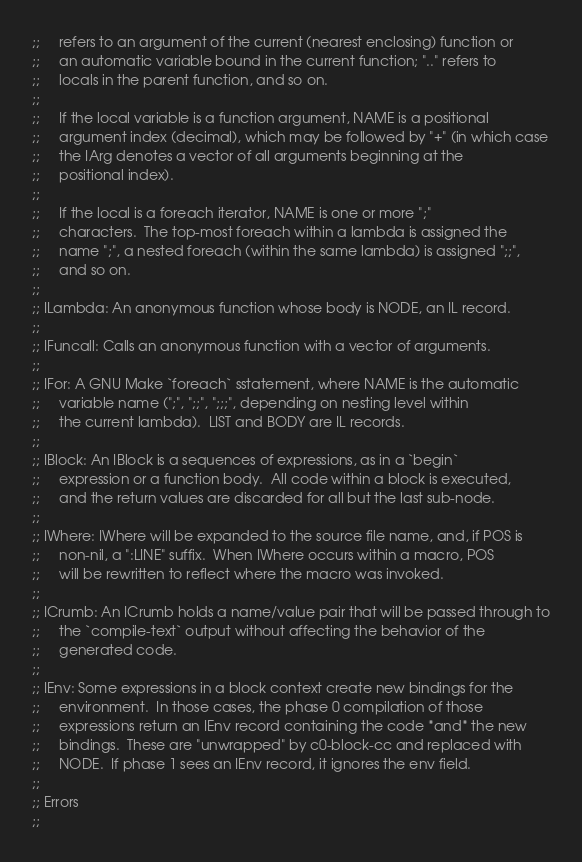<code> <loc_0><loc_0><loc_500><loc_500><_Scheme_>;;     refers to an argument of the current (nearest enclosing) function or
;;     an automatic variable bound in the current function; ".." refers to
;;     locals in the parent function, and so on.
;;
;;     If the local variable is a function argument, NAME is a positional
;;     argument index (decimal), which may be followed by "+" (in which case
;;     the IArg denotes a vector of all arguments beginning at the
;;     positional index).
;;
;;     If the local is a foreach iterator, NAME is one or more ";"
;;     characters.  The top-most foreach within a lambda is assigned the
;;     name ";", a nested foreach (within the same lambda) is assigned ";;",
;;     and so on.
;;
;; ILambda: An anonymous function whose body is NODE, an IL record.
;;
;; IFuncall: Calls an anonymous function with a vector of arguments.
;;
;; IFor: A GNU Make `foreach` sstatement, where NAME is the automatic
;;     variable name (";", ";;", ";;;", depending on nesting level within
;;     the current lambda).  LIST and BODY are IL records.
;;
;; IBlock: An IBlock is a sequences of expressions, as in a `begin`
;;     expression or a function body.  All code within a block is executed,
;;     and the return values are discarded for all but the last sub-node.
;;
;; IWhere: IWhere will be expanded to the source file name, and, if POS is
;;     non-nil, a ":LINE" suffix.  When IWhere occurs within a macro, POS
;;     will be rewritten to reflect where the macro was invoked.
;;
;; ICrumb: An ICrumb holds a name/value pair that will be passed through to
;;     the `compile-text` output without affecting the behavior of the
;;     generated code.
;;
;; IEnv: Some expressions in a block context create new bindings for the
;;     environment.  In those cases, the phase 0 compilation of those
;;     expressions return an IEnv record containing the code *and* the new
;;     bindings.  These are "unwrapped" by c0-block-cc and replaced with
;;     NODE.  If phase 1 sees an IEnv record, it ignores the env field.
;;
;; Errors
;;</code> 